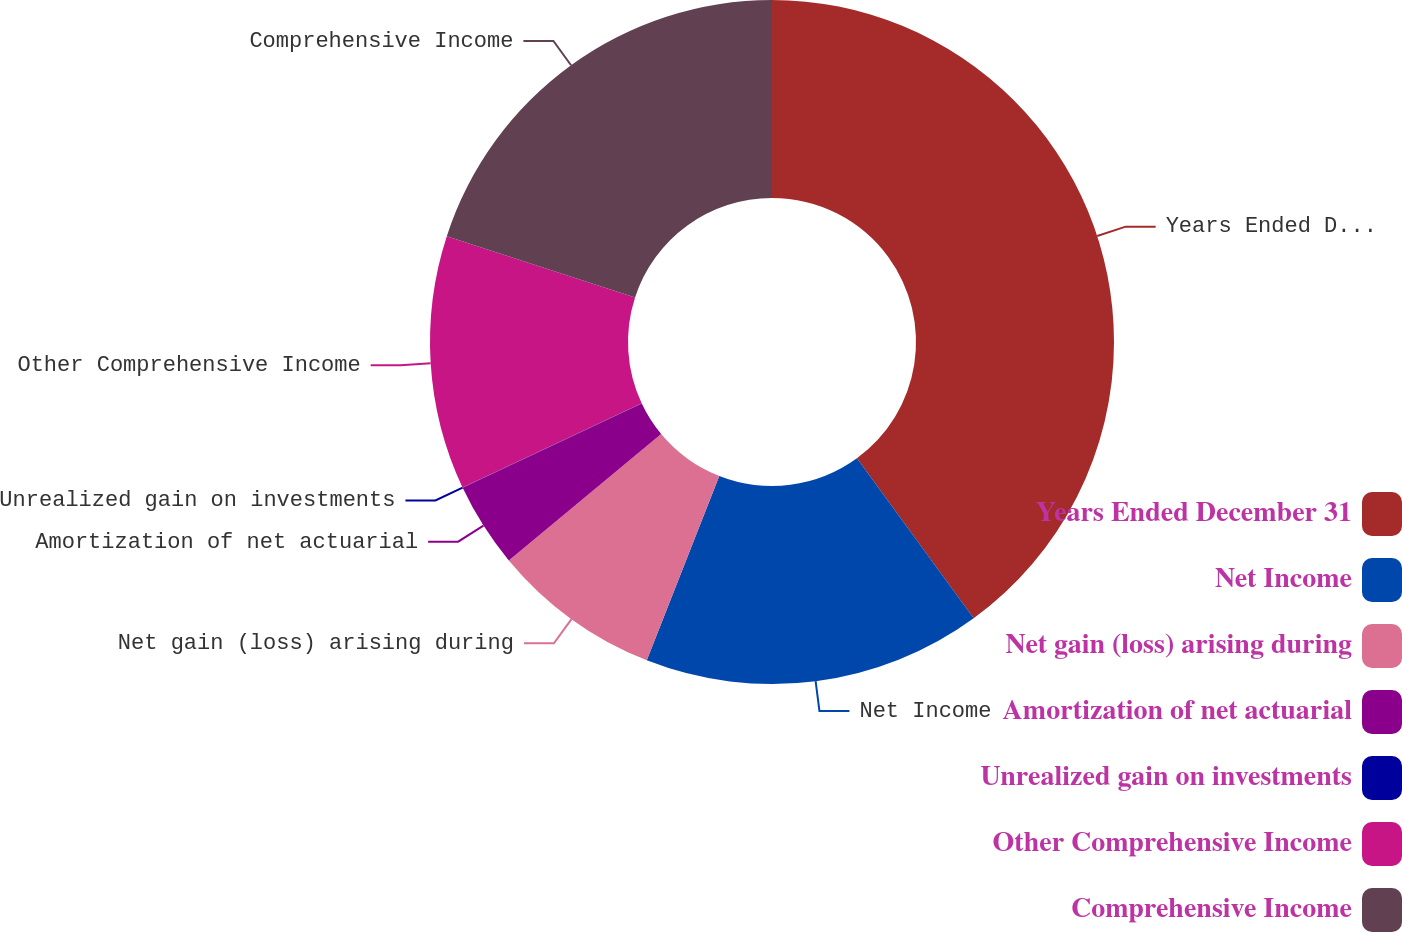<chart> <loc_0><loc_0><loc_500><loc_500><pie_chart><fcel>Years Ended December 31<fcel>Net Income<fcel>Net gain (loss) arising during<fcel>Amortization of net actuarial<fcel>Unrealized gain on investments<fcel>Other Comprehensive Income<fcel>Comprehensive Income<nl><fcel>39.96%<fcel>16.0%<fcel>8.01%<fcel>4.01%<fcel>0.02%<fcel>12.0%<fcel>19.99%<nl></chart> 